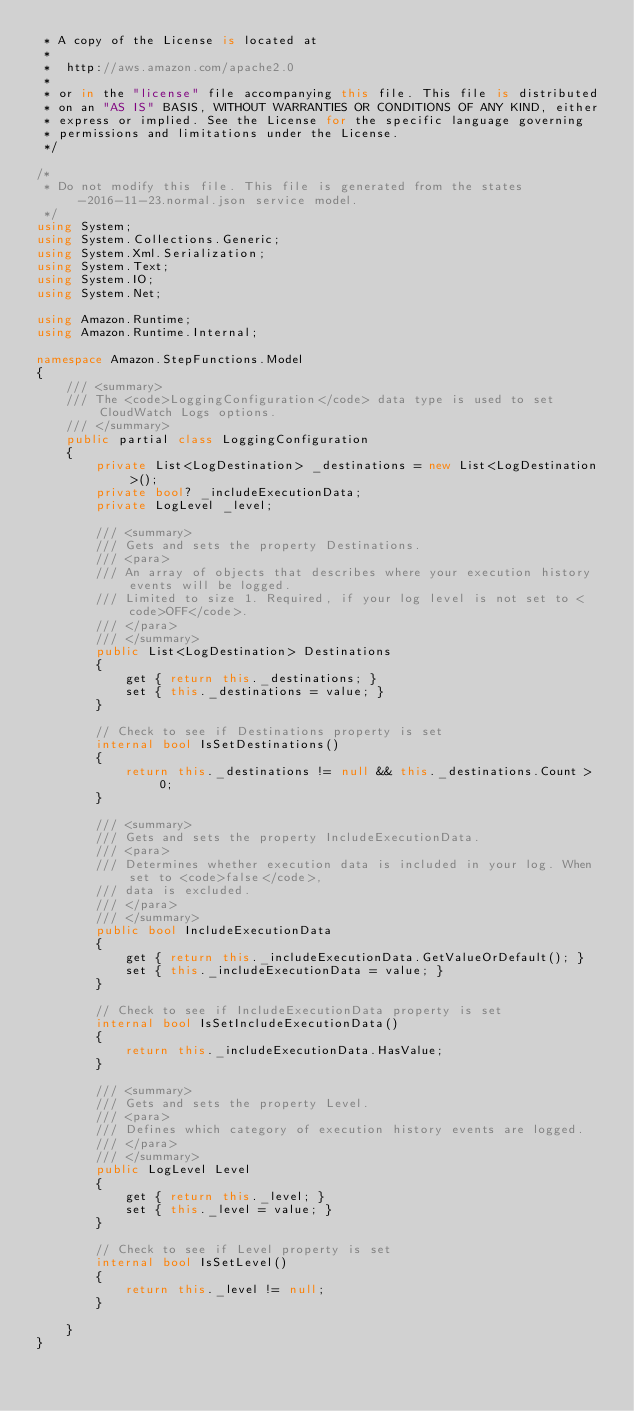<code> <loc_0><loc_0><loc_500><loc_500><_C#_> * A copy of the License is located at
 * 
 *  http://aws.amazon.com/apache2.0
 * 
 * or in the "license" file accompanying this file. This file is distributed
 * on an "AS IS" BASIS, WITHOUT WARRANTIES OR CONDITIONS OF ANY KIND, either
 * express or implied. See the License for the specific language governing
 * permissions and limitations under the License.
 */

/*
 * Do not modify this file. This file is generated from the states-2016-11-23.normal.json service model.
 */
using System;
using System.Collections.Generic;
using System.Xml.Serialization;
using System.Text;
using System.IO;
using System.Net;

using Amazon.Runtime;
using Amazon.Runtime.Internal;

namespace Amazon.StepFunctions.Model
{
    /// <summary>
    /// The <code>LoggingConfiguration</code> data type is used to set CloudWatch Logs options.
    /// </summary>
    public partial class LoggingConfiguration
    {
        private List<LogDestination> _destinations = new List<LogDestination>();
        private bool? _includeExecutionData;
        private LogLevel _level;

        /// <summary>
        /// Gets and sets the property Destinations. 
        /// <para>
        /// An array of objects that describes where your execution history events will be logged.
        /// Limited to size 1. Required, if your log level is not set to <code>OFF</code>.
        /// </para>
        /// </summary>
        public List<LogDestination> Destinations
        {
            get { return this._destinations; }
            set { this._destinations = value; }
        }

        // Check to see if Destinations property is set
        internal bool IsSetDestinations()
        {
            return this._destinations != null && this._destinations.Count > 0; 
        }

        /// <summary>
        /// Gets and sets the property IncludeExecutionData. 
        /// <para>
        /// Determines whether execution data is included in your log. When set to <code>false</code>,
        /// data is excluded.
        /// </para>
        /// </summary>
        public bool IncludeExecutionData
        {
            get { return this._includeExecutionData.GetValueOrDefault(); }
            set { this._includeExecutionData = value; }
        }

        // Check to see if IncludeExecutionData property is set
        internal bool IsSetIncludeExecutionData()
        {
            return this._includeExecutionData.HasValue; 
        }

        /// <summary>
        /// Gets and sets the property Level. 
        /// <para>
        /// Defines which category of execution history events are logged.
        /// </para>
        /// </summary>
        public LogLevel Level
        {
            get { return this._level; }
            set { this._level = value; }
        }

        // Check to see if Level property is set
        internal bool IsSetLevel()
        {
            return this._level != null;
        }

    }
}</code> 